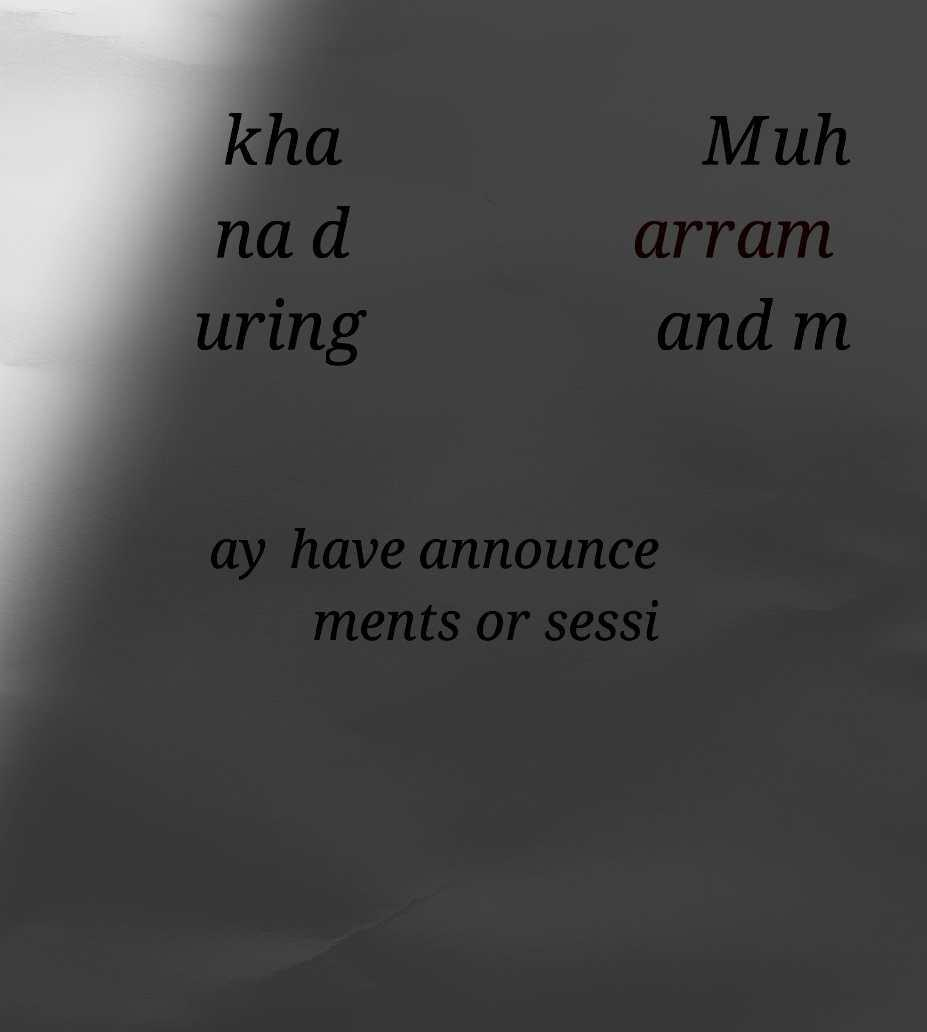Could you extract and type out the text from this image? kha na d uring Muh arram and m ay have announce ments or sessi 